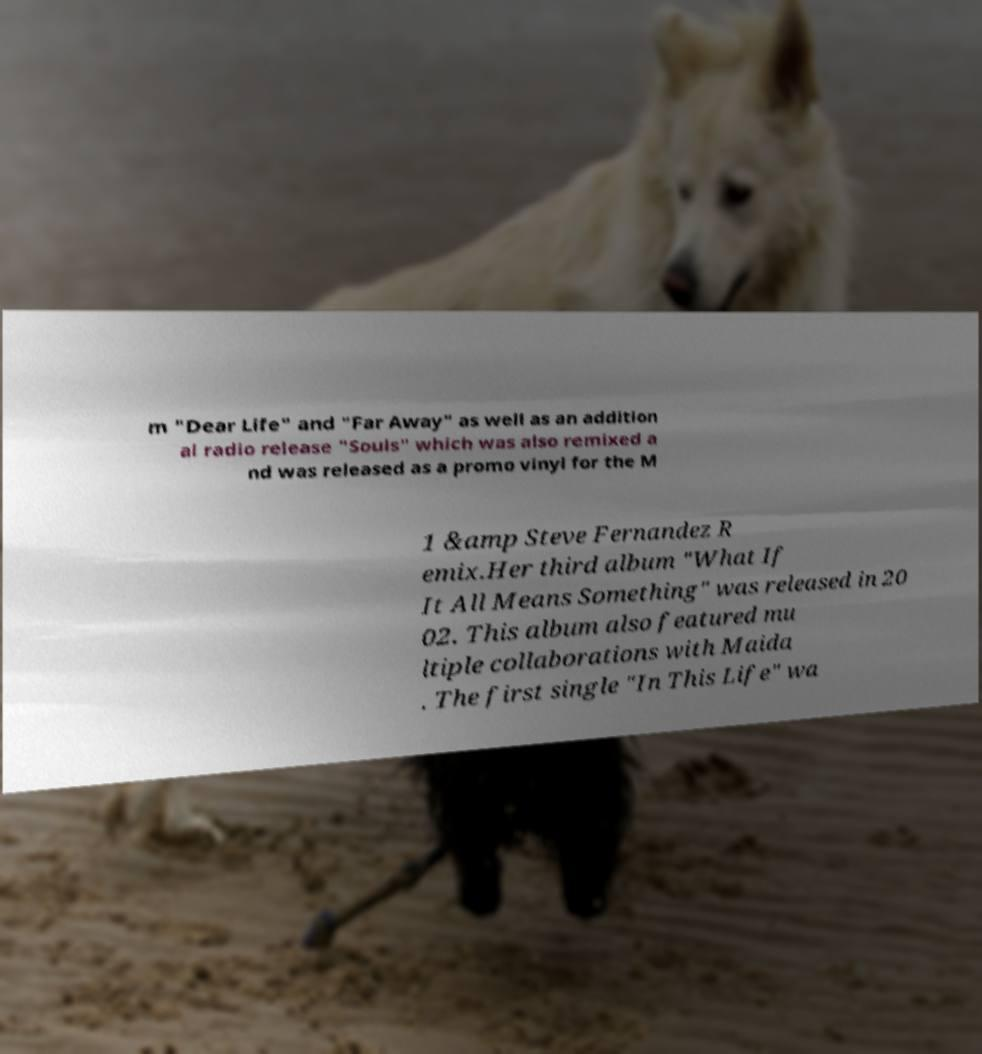What messages or text are displayed in this image? I need them in a readable, typed format. m "Dear Life" and "Far Away" as well as an addition al radio release "Souls" which was also remixed a nd was released as a promo vinyl for the M 1 &amp Steve Fernandez R emix.Her third album "What If It All Means Something" was released in 20 02. This album also featured mu ltiple collaborations with Maida . The first single "In This Life" wa 